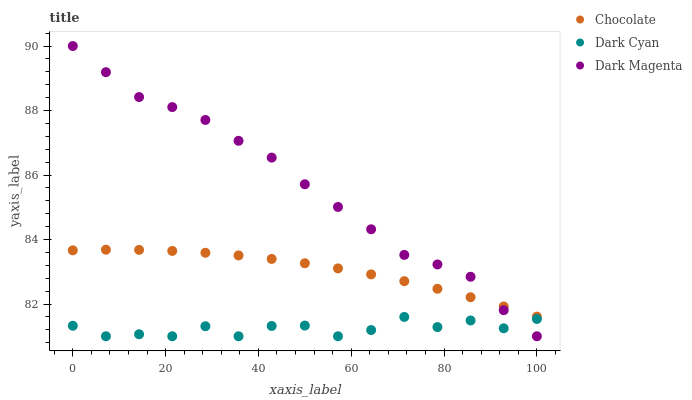Does Dark Cyan have the minimum area under the curve?
Answer yes or no. Yes. Does Dark Magenta have the maximum area under the curve?
Answer yes or no. Yes. Does Chocolate have the minimum area under the curve?
Answer yes or no. No. Does Chocolate have the maximum area under the curve?
Answer yes or no. No. Is Chocolate the smoothest?
Answer yes or no. Yes. Is Dark Cyan the roughest?
Answer yes or no. Yes. Is Dark Magenta the smoothest?
Answer yes or no. No. Is Dark Magenta the roughest?
Answer yes or no. No. Does Dark Cyan have the lowest value?
Answer yes or no. Yes. Does Chocolate have the lowest value?
Answer yes or no. No. Does Dark Magenta have the highest value?
Answer yes or no. Yes. Does Chocolate have the highest value?
Answer yes or no. No. Is Dark Cyan less than Chocolate?
Answer yes or no. Yes. Is Chocolate greater than Dark Cyan?
Answer yes or no. Yes. Does Dark Magenta intersect Chocolate?
Answer yes or no. Yes. Is Dark Magenta less than Chocolate?
Answer yes or no. No. Is Dark Magenta greater than Chocolate?
Answer yes or no. No. Does Dark Cyan intersect Chocolate?
Answer yes or no. No. 